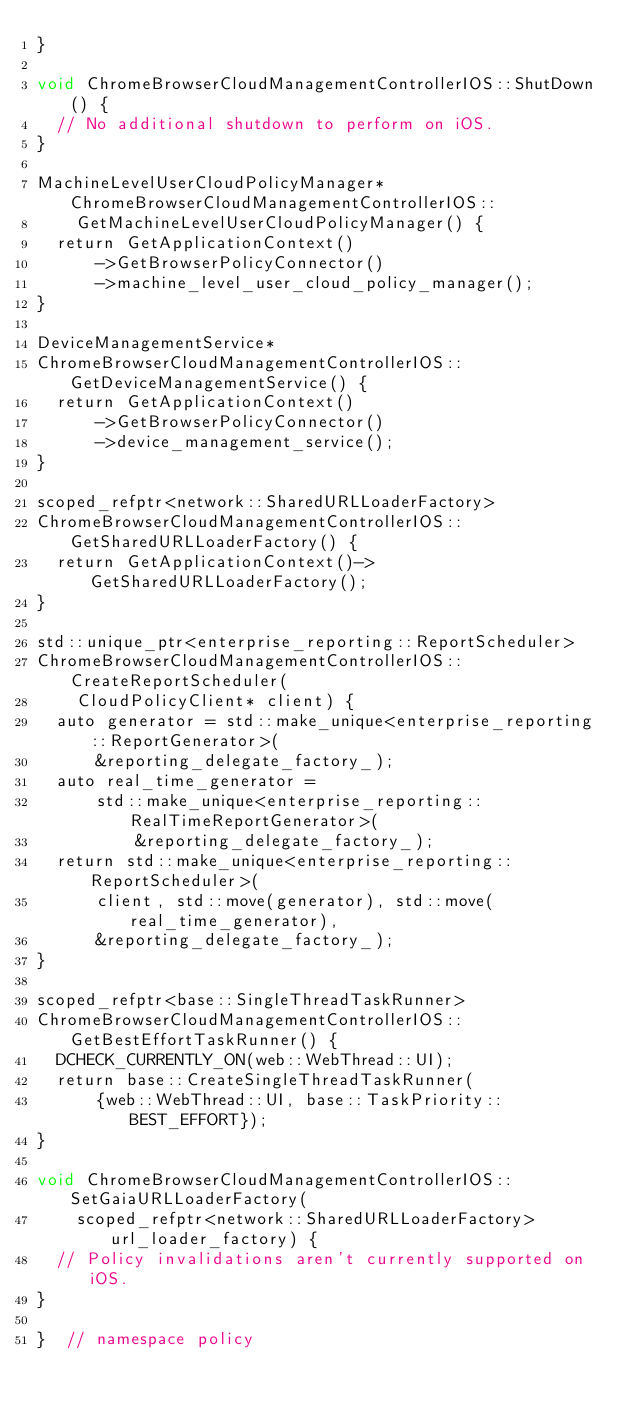<code> <loc_0><loc_0><loc_500><loc_500><_ObjectiveC_>}

void ChromeBrowserCloudManagementControllerIOS::ShutDown() {
  // No additional shutdown to perform on iOS.
}

MachineLevelUserCloudPolicyManager* ChromeBrowserCloudManagementControllerIOS::
    GetMachineLevelUserCloudPolicyManager() {
  return GetApplicationContext()
      ->GetBrowserPolicyConnector()
      ->machine_level_user_cloud_policy_manager();
}

DeviceManagementService*
ChromeBrowserCloudManagementControllerIOS::GetDeviceManagementService() {
  return GetApplicationContext()
      ->GetBrowserPolicyConnector()
      ->device_management_service();
}

scoped_refptr<network::SharedURLLoaderFactory>
ChromeBrowserCloudManagementControllerIOS::GetSharedURLLoaderFactory() {
  return GetApplicationContext()->GetSharedURLLoaderFactory();
}

std::unique_ptr<enterprise_reporting::ReportScheduler>
ChromeBrowserCloudManagementControllerIOS::CreateReportScheduler(
    CloudPolicyClient* client) {
  auto generator = std::make_unique<enterprise_reporting::ReportGenerator>(
      &reporting_delegate_factory_);
  auto real_time_generator =
      std::make_unique<enterprise_reporting::RealTimeReportGenerator>(
          &reporting_delegate_factory_);
  return std::make_unique<enterprise_reporting::ReportScheduler>(
      client, std::move(generator), std::move(real_time_generator),
      &reporting_delegate_factory_);
}

scoped_refptr<base::SingleThreadTaskRunner>
ChromeBrowserCloudManagementControllerIOS::GetBestEffortTaskRunner() {
  DCHECK_CURRENTLY_ON(web::WebThread::UI);
  return base::CreateSingleThreadTaskRunner(
      {web::WebThread::UI, base::TaskPriority::BEST_EFFORT});
}

void ChromeBrowserCloudManagementControllerIOS::SetGaiaURLLoaderFactory(
    scoped_refptr<network::SharedURLLoaderFactory> url_loader_factory) {
  // Policy invalidations aren't currently supported on iOS.
}

}  // namespace policy
</code> 